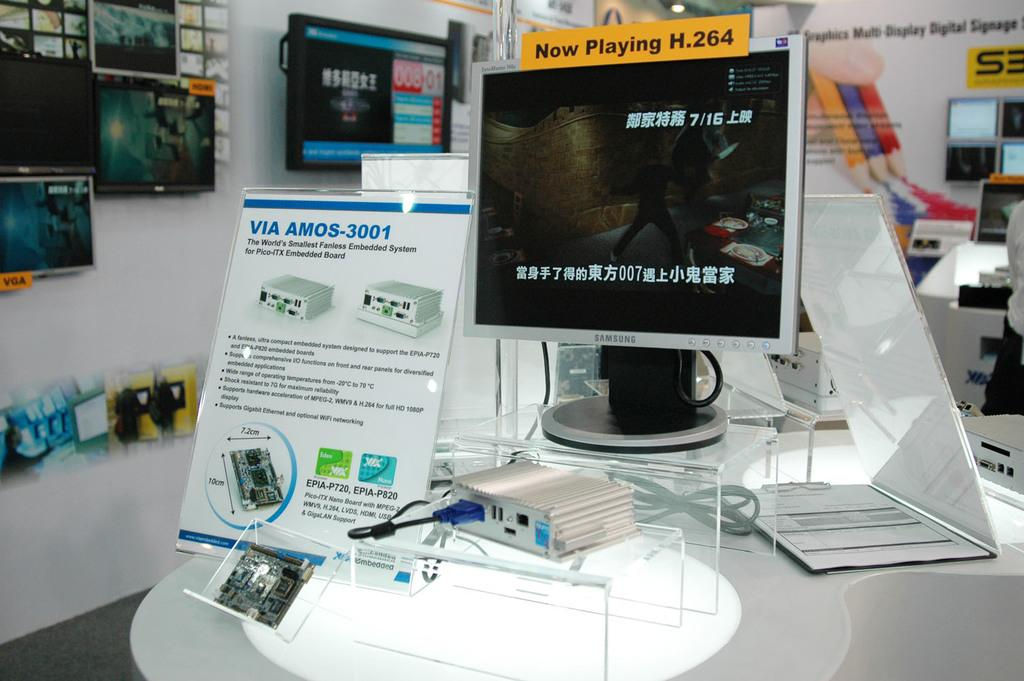<image>
Share a concise interpretation of the image provided. Samsung monitor inside of a store that has a tag saying "Now Playing". 